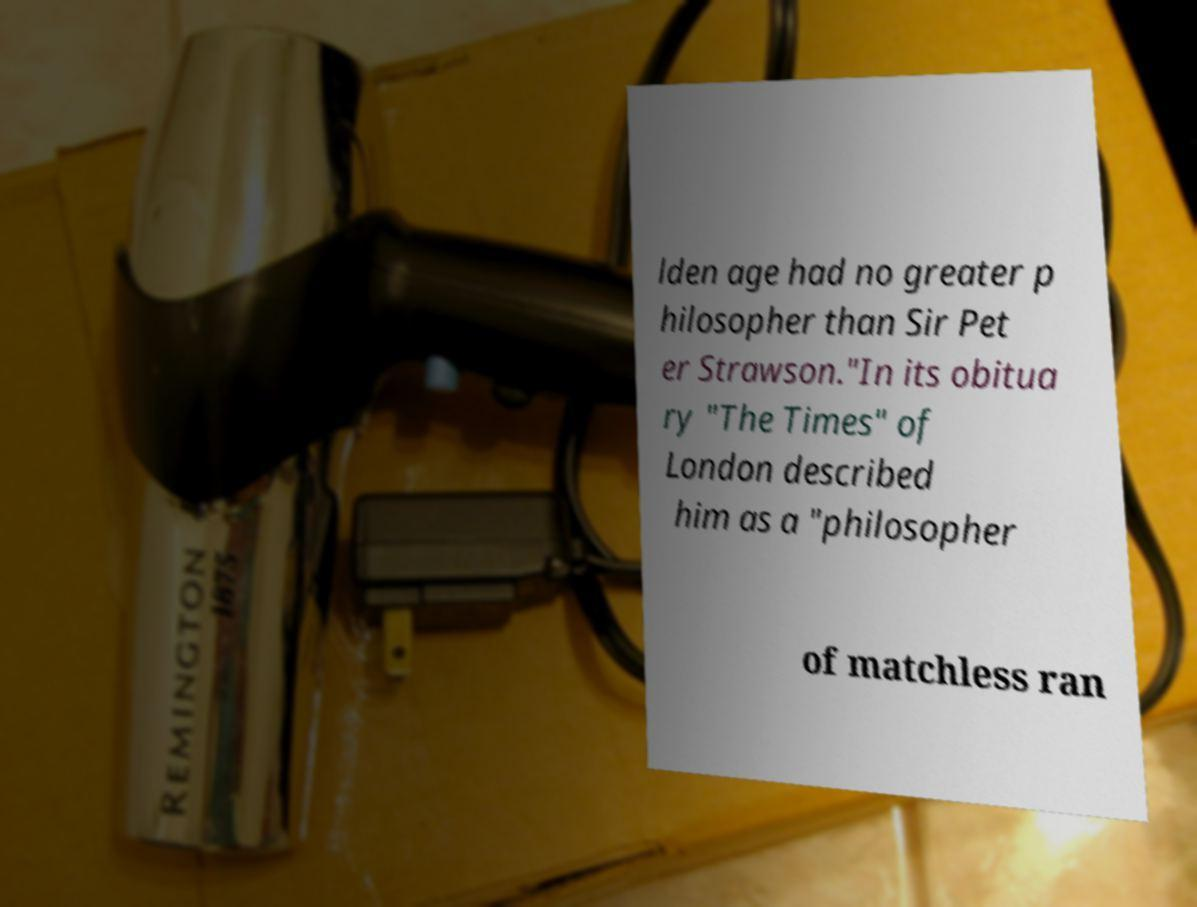Can you read and provide the text displayed in the image?This photo seems to have some interesting text. Can you extract and type it out for me? lden age had no greater p hilosopher than Sir Pet er Strawson."In its obitua ry "The Times" of London described him as a "philosopher of matchless ran 